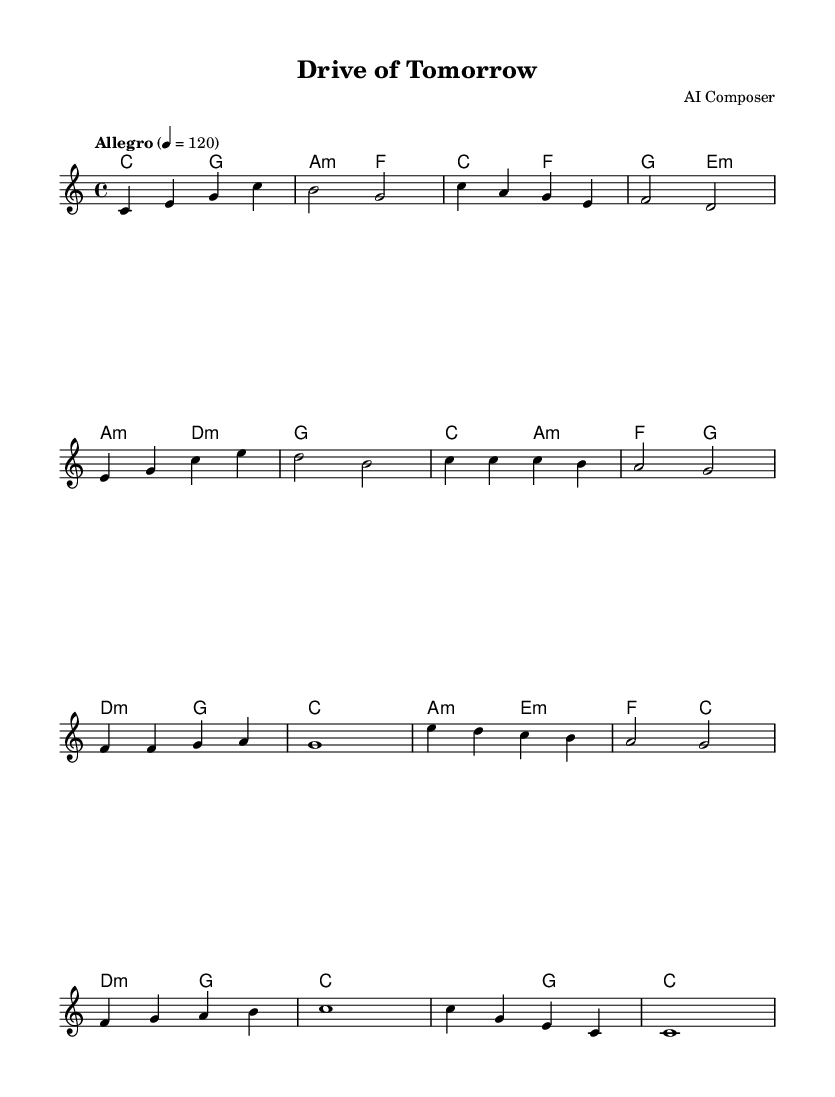What is the key signature of this music? The key signature is indicated at the beginning of the piece, showing that it is in C major, which has no sharps or flats.
Answer: C major What is the time signature of this music? The time signature appears at the beginning and is noted as 4/4, meaning there are four beats per measure and the quarter note gets one beat.
Answer: 4/4 What is the tempo marking for this piece? The tempo marking is provided above the staff, indicating "Allegro" with a metronome marking of 120 beats per minute, suggesting a fast and lively tempo.
Answer: Allegro 4 = 120 How many measures are in the chorus section? By examining the score, the chorus section spans four measures, which can be counted in the melody notation, depicting the repetition of thematic material.
Answer: 4 What is the final chord played in the outro? The last measure shows a C major chord, which is the final harmonic resolution of the piece, typically indicating the end of the musical phrase or piece.
Answer: C What is the duration of the last note in the outro? The last note in the outro is a whole note (c1), which is represented as occupying an entire measure, indicating its full duration in the rhythm.
Answer: Whole note What musical form does this piece exhibit? The piece exhibits a simple verse-chorus form, identifiable from the distinct sections labeled as verse and chorus, showing a repeated structure common in popular music.
Answer: Verse-Chorus 